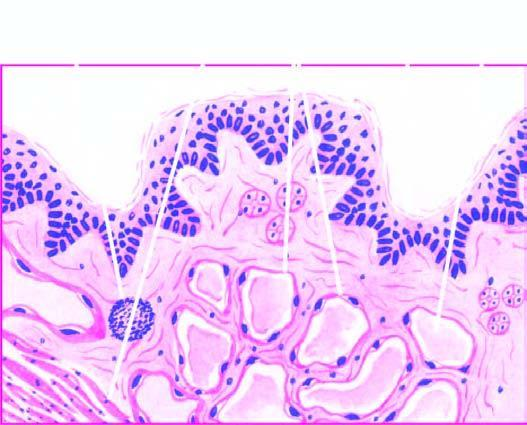what shows scattered collection of lymphocytes?
Answer the question using a single word or phrase. Stroma 